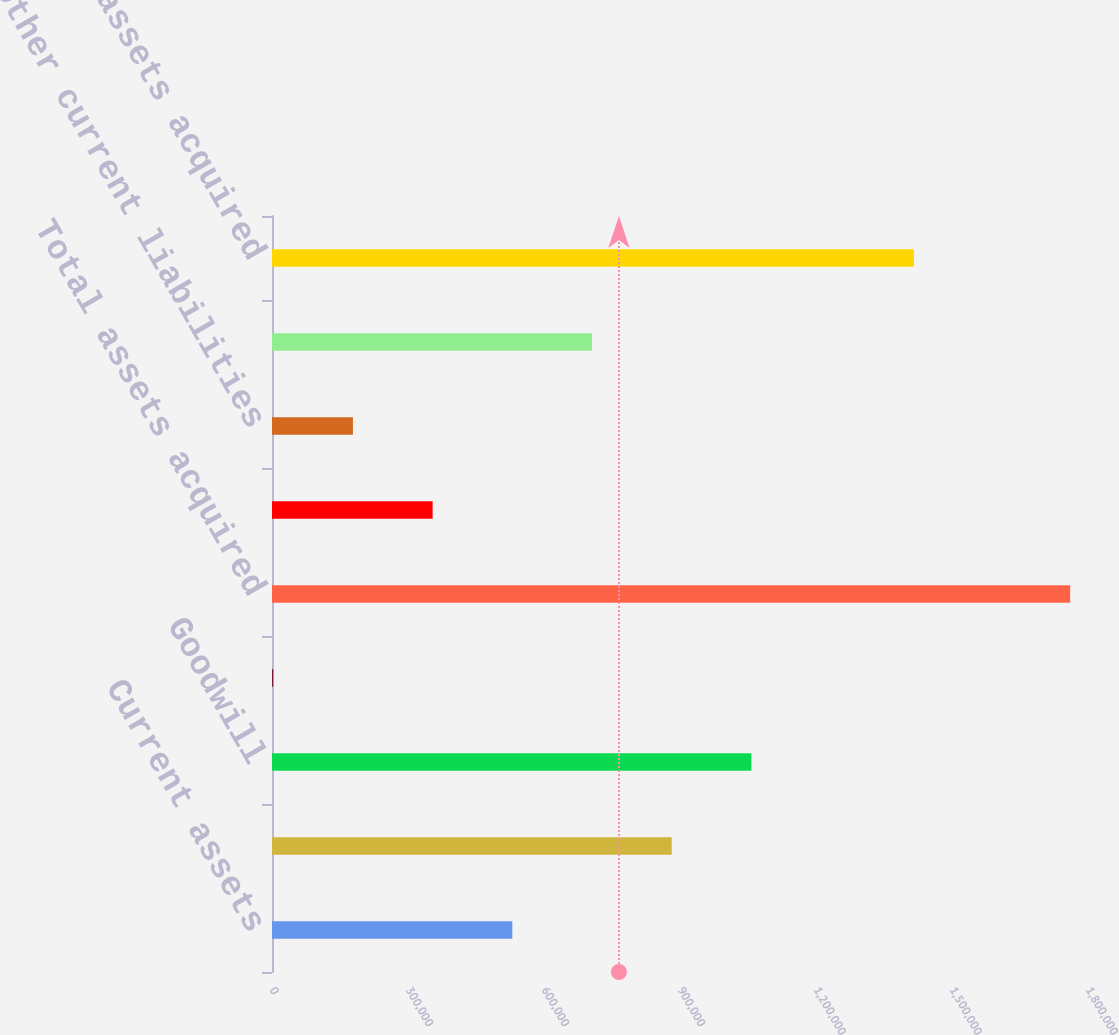Convert chart. <chart><loc_0><loc_0><loc_500><loc_500><bar_chart><fcel>Current assets<fcel>Identifiable intangibles<fcel>Goodwill<fcel>Other assets<fcel>Total assets acquired<fcel>Deferred revenue<fcel>Other current liabilities<fcel>Long-term deferred tax<fcel>Net assets acquired<nl><fcel>530108<fcel>881718<fcel>1.05752e+06<fcel>2694<fcel>1.76074e+06<fcel>354303<fcel>178499<fcel>705913<fcel>1.41598e+06<nl></chart> 